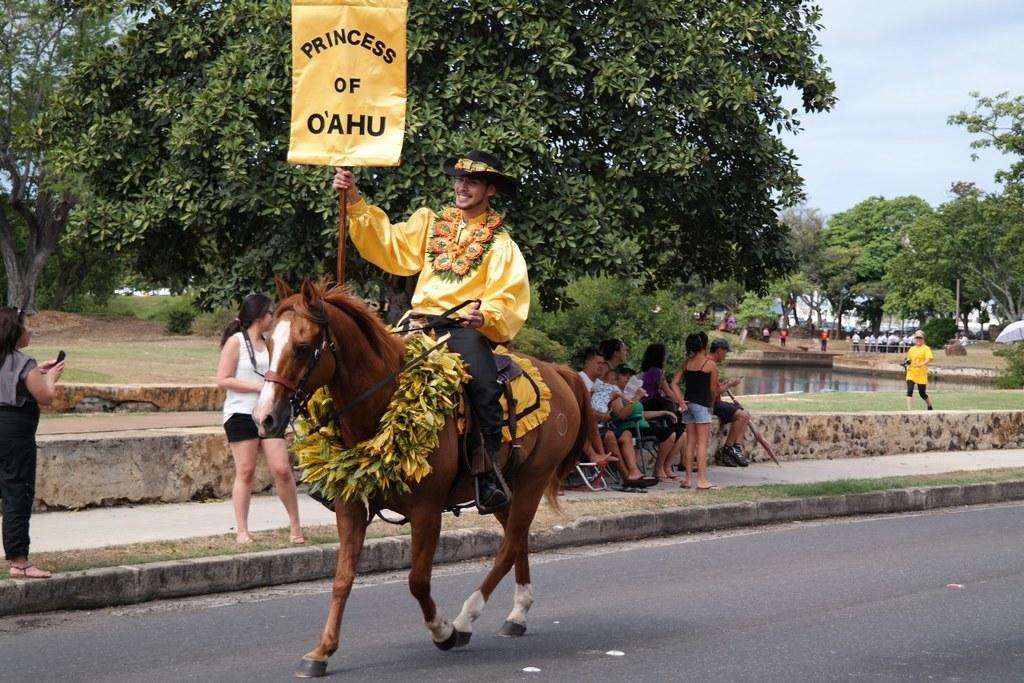In one or two sentences, can you explain what this image depicts? In this image there is the sky towards the top of the image, there are trees towards the top of the image, there are trees towards the right of the image, there are group of persons standing, there are group of persons sitting, there is a man sitting on the horse, he is holding an object, there is road towards the bottom of the image, there is grass, there is a woman standing towards the left of the image, she is holding an object. 